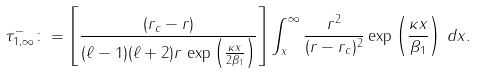Convert formula to latex. <formula><loc_0><loc_0><loc_500><loc_500>\tau _ { 1 , \infty } ^ { - } \colon = \left [ \frac { ( r _ { c } - r ) } { ( \ell - 1 ) ( \ell + 2 ) r \, \exp \left ( \frac { \kappa x } { 2 \beta _ { 1 } } \right ) } \right ] \int _ { x } ^ { \infty } \frac { r ^ { 2 } } { ( r - r _ { c } ) ^ { 2 } } \exp \left ( \frac { \kappa x } { \beta _ { 1 } } \right ) \, d x .</formula> 